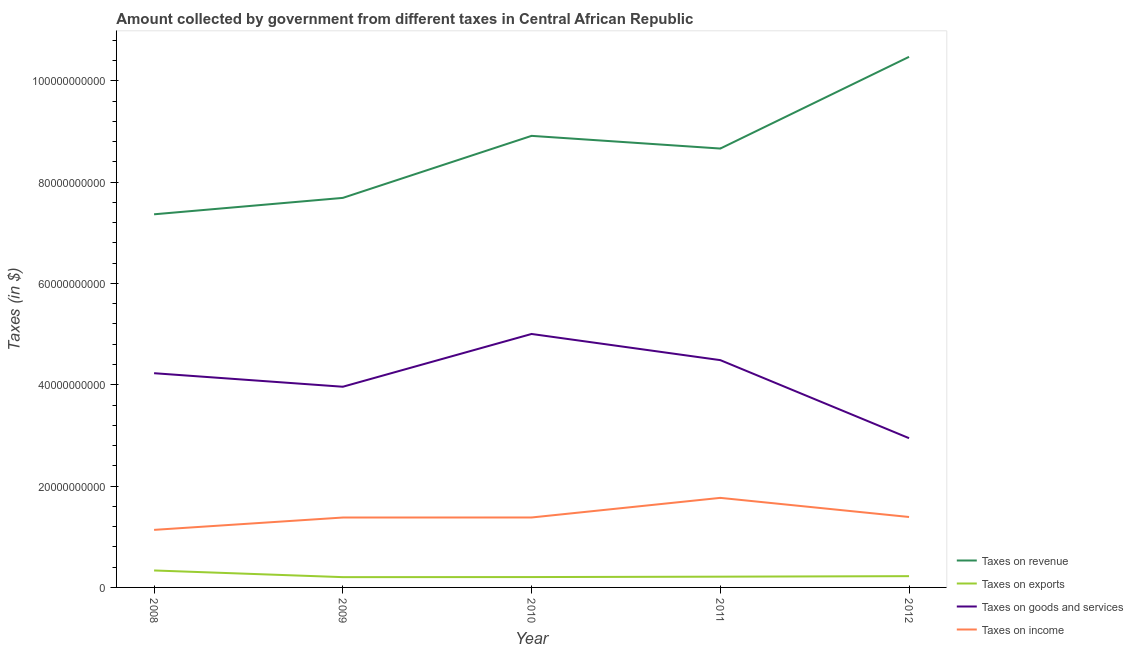What is the amount collected as tax on goods in 2008?
Ensure brevity in your answer.  4.23e+1. Across all years, what is the maximum amount collected as tax on exports?
Offer a terse response. 3.35e+09. Across all years, what is the minimum amount collected as tax on goods?
Keep it short and to the point. 2.95e+1. In which year was the amount collected as tax on goods maximum?
Your response must be concise. 2010. In which year was the amount collected as tax on revenue minimum?
Your response must be concise. 2008. What is the total amount collected as tax on goods in the graph?
Offer a terse response. 2.06e+11. What is the difference between the amount collected as tax on revenue in 2011 and that in 2012?
Make the answer very short. -1.81e+1. What is the difference between the amount collected as tax on exports in 2012 and the amount collected as tax on goods in 2008?
Ensure brevity in your answer.  -4.01e+1. What is the average amount collected as tax on exports per year?
Provide a succinct answer. 2.35e+09. In the year 2009, what is the difference between the amount collected as tax on income and amount collected as tax on goods?
Ensure brevity in your answer.  -2.58e+1. What is the ratio of the amount collected as tax on exports in 2008 to that in 2011?
Your response must be concise. 1.58. Is the difference between the amount collected as tax on goods in 2009 and 2011 greater than the difference between the amount collected as tax on income in 2009 and 2011?
Provide a succinct answer. No. What is the difference between the highest and the second highest amount collected as tax on revenue?
Offer a very short reply. 1.56e+1. What is the difference between the highest and the lowest amount collected as tax on goods?
Make the answer very short. 2.06e+1. Is it the case that in every year, the sum of the amount collected as tax on exports and amount collected as tax on goods is greater than the sum of amount collected as tax on revenue and amount collected as tax on income?
Your answer should be very brief. Yes. Is it the case that in every year, the sum of the amount collected as tax on revenue and amount collected as tax on exports is greater than the amount collected as tax on goods?
Offer a very short reply. Yes. Does the amount collected as tax on goods monotonically increase over the years?
Your answer should be compact. No. Is the amount collected as tax on revenue strictly greater than the amount collected as tax on goods over the years?
Your answer should be very brief. Yes. Is the amount collected as tax on revenue strictly less than the amount collected as tax on goods over the years?
Your response must be concise. No. How many lines are there?
Provide a short and direct response. 4. How many years are there in the graph?
Give a very brief answer. 5. Does the graph contain grids?
Provide a succinct answer. No. How many legend labels are there?
Your answer should be compact. 4. How are the legend labels stacked?
Your answer should be compact. Vertical. What is the title of the graph?
Give a very brief answer. Amount collected by government from different taxes in Central African Republic. Does "Others" appear as one of the legend labels in the graph?
Make the answer very short. No. What is the label or title of the X-axis?
Ensure brevity in your answer.  Year. What is the label or title of the Y-axis?
Your answer should be compact. Taxes (in $). What is the Taxes (in $) of Taxes on revenue in 2008?
Keep it short and to the point. 7.37e+1. What is the Taxes (in $) in Taxes on exports in 2008?
Your answer should be very brief. 3.35e+09. What is the Taxes (in $) of Taxes on goods and services in 2008?
Your response must be concise. 4.23e+1. What is the Taxes (in $) in Taxes on income in 2008?
Give a very brief answer. 1.14e+1. What is the Taxes (in $) of Taxes on revenue in 2009?
Your response must be concise. 7.69e+1. What is the Taxes (in $) of Taxes on exports in 2009?
Provide a short and direct response. 2.03e+09. What is the Taxes (in $) in Taxes on goods and services in 2009?
Your answer should be very brief. 3.96e+1. What is the Taxes (in $) of Taxes on income in 2009?
Provide a short and direct response. 1.38e+1. What is the Taxes (in $) in Taxes on revenue in 2010?
Provide a short and direct response. 8.91e+1. What is the Taxes (in $) in Taxes on exports in 2010?
Your answer should be compact. 2.05e+09. What is the Taxes (in $) in Taxes on goods and services in 2010?
Your answer should be compact. 5.00e+1. What is the Taxes (in $) of Taxes on income in 2010?
Provide a succinct answer. 1.38e+1. What is the Taxes (in $) of Taxes on revenue in 2011?
Provide a short and direct response. 8.66e+1. What is the Taxes (in $) of Taxes on exports in 2011?
Ensure brevity in your answer.  2.12e+09. What is the Taxes (in $) in Taxes on goods and services in 2011?
Offer a very short reply. 4.49e+1. What is the Taxes (in $) of Taxes on income in 2011?
Your response must be concise. 1.77e+1. What is the Taxes (in $) in Taxes on revenue in 2012?
Make the answer very short. 1.05e+11. What is the Taxes (in $) in Taxes on exports in 2012?
Provide a succinct answer. 2.23e+09. What is the Taxes (in $) of Taxes on goods and services in 2012?
Your response must be concise. 2.95e+1. What is the Taxes (in $) of Taxes on income in 2012?
Your answer should be very brief. 1.39e+1. Across all years, what is the maximum Taxes (in $) of Taxes on revenue?
Your response must be concise. 1.05e+11. Across all years, what is the maximum Taxes (in $) in Taxes on exports?
Your response must be concise. 3.35e+09. Across all years, what is the maximum Taxes (in $) of Taxes on goods and services?
Make the answer very short. 5.00e+1. Across all years, what is the maximum Taxes (in $) of Taxes on income?
Ensure brevity in your answer.  1.77e+1. Across all years, what is the minimum Taxes (in $) of Taxes on revenue?
Your response must be concise. 7.37e+1. Across all years, what is the minimum Taxes (in $) of Taxes on exports?
Your answer should be very brief. 2.03e+09. Across all years, what is the minimum Taxes (in $) in Taxes on goods and services?
Provide a short and direct response. 2.95e+1. Across all years, what is the minimum Taxes (in $) in Taxes on income?
Provide a short and direct response. 1.14e+1. What is the total Taxes (in $) of Taxes on revenue in the graph?
Your answer should be compact. 4.31e+11. What is the total Taxes (in $) of Taxes on exports in the graph?
Provide a short and direct response. 1.18e+1. What is the total Taxes (in $) in Taxes on goods and services in the graph?
Ensure brevity in your answer.  2.06e+11. What is the total Taxes (in $) in Taxes on income in the graph?
Provide a short and direct response. 7.05e+1. What is the difference between the Taxes (in $) of Taxes on revenue in 2008 and that in 2009?
Ensure brevity in your answer.  -3.24e+09. What is the difference between the Taxes (in $) of Taxes on exports in 2008 and that in 2009?
Your response must be concise. 1.32e+09. What is the difference between the Taxes (in $) of Taxes on goods and services in 2008 and that in 2009?
Keep it short and to the point. 2.67e+09. What is the difference between the Taxes (in $) of Taxes on income in 2008 and that in 2009?
Your response must be concise. -2.44e+09. What is the difference between the Taxes (in $) of Taxes on revenue in 2008 and that in 2010?
Make the answer very short. -1.55e+1. What is the difference between the Taxes (in $) in Taxes on exports in 2008 and that in 2010?
Provide a succinct answer. 1.30e+09. What is the difference between the Taxes (in $) in Taxes on goods and services in 2008 and that in 2010?
Give a very brief answer. -7.75e+09. What is the difference between the Taxes (in $) of Taxes on income in 2008 and that in 2010?
Provide a short and direct response. -2.44e+09. What is the difference between the Taxes (in $) of Taxes on revenue in 2008 and that in 2011?
Give a very brief answer. -1.30e+1. What is the difference between the Taxes (in $) in Taxes on exports in 2008 and that in 2011?
Keep it short and to the point. 1.22e+09. What is the difference between the Taxes (in $) of Taxes on goods and services in 2008 and that in 2011?
Keep it short and to the point. -2.58e+09. What is the difference between the Taxes (in $) of Taxes on income in 2008 and that in 2011?
Provide a succinct answer. -6.32e+09. What is the difference between the Taxes (in $) in Taxes on revenue in 2008 and that in 2012?
Provide a short and direct response. -3.11e+1. What is the difference between the Taxes (in $) in Taxes on exports in 2008 and that in 2012?
Give a very brief answer. 1.12e+09. What is the difference between the Taxes (in $) in Taxes on goods and services in 2008 and that in 2012?
Your answer should be very brief. 1.28e+1. What is the difference between the Taxes (in $) in Taxes on income in 2008 and that in 2012?
Make the answer very short. -2.54e+09. What is the difference between the Taxes (in $) in Taxes on revenue in 2009 and that in 2010?
Offer a terse response. -1.22e+1. What is the difference between the Taxes (in $) in Taxes on exports in 2009 and that in 2010?
Keep it short and to the point. -1.71e+07. What is the difference between the Taxes (in $) in Taxes on goods and services in 2009 and that in 2010?
Provide a short and direct response. -1.04e+1. What is the difference between the Taxes (in $) in Taxes on income in 2009 and that in 2010?
Provide a short and direct response. -7.21e+06. What is the difference between the Taxes (in $) of Taxes on revenue in 2009 and that in 2011?
Your answer should be very brief. -9.74e+09. What is the difference between the Taxes (in $) in Taxes on exports in 2009 and that in 2011?
Provide a short and direct response. -9.30e+07. What is the difference between the Taxes (in $) in Taxes on goods and services in 2009 and that in 2011?
Provide a short and direct response. -5.25e+09. What is the difference between the Taxes (in $) in Taxes on income in 2009 and that in 2011?
Keep it short and to the point. -3.88e+09. What is the difference between the Taxes (in $) of Taxes on revenue in 2009 and that in 2012?
Keep it short and to the point. -2.78e+1. What is the difference between the Taxes (in $) of Taxes on exports in 2009 and that in 2012?
Provide a short and direct response. -1.96e+08. What is the difference between the Taxes (in $) in Taxes on goods and services in 2009 and that in 2012?
Ensure brevity in your answer.  1.02e+1. What is the difference between the Taxes (in $) of Taxes on income in 2009 and that in 2012?
Provide a succinct answer. -1.05e+08. What is the difference between the Taxes (in $) in Taxes on revenue in 2010 and that in 2011?
Your response must be concise. 2.50e+09. What is the difference between the Taxes (in $) of Taxes on exports in 2010 and that in 2011?
Make the answer very short. -7.59e+07. What is the difference between the Taxes (in $) in Taxes on goods and services in 2010 and that in 2011?
Give a very brief answer. 5.16e+09. What is the difference between the Taxes (in $) of Taxes on income in 2010 and that in 2011?
Offer a very short reply. -3.87e+09. What is the difference between the Taxes (in $) of Taxes on revenue in 2010 and that in 2012?
Ensure brevity in your answer.  -1.56e+1. What is the difference between the Taxes (in $) of Taxes on exports in 2010 and that in 2012?
Make the answer very short. -1.79e+08. What is the difference between the Taxes (in $) of Taxes on goods and services in 2010 and that in 2012?
Provide a short and direct response. 2.06e+1. What is the difference between the Taxes (in $) of Taxes on income in 2010 and that in 2012?
Your answer should be very brief. -9.73e+07. What is the difference between the Taxes (in $) in Taxes on revenue in 2011 and that in 2012?
Provide a short and direct response. -1.81e+1. What is the difference between the Taxes (in $) in Taxes on exports in 2011 and that in 2012?
Ensure brevity in your answer.  -1.03e+08. What is the difference between the Taxes (in $) in Taxes on goods and services in 2011 and that in 2012?
Make the answer very short. 1.54e+1. What is the difference between the Taxes (in $) in Taxes on income in 2011 and that in 2012?
Your answer should be very brief. 3.78e+09. What is the difference between the Taxes (in $) in Taxes on revenue in 2008 and the Taxes (in $) in Taxes on exports in 2009?
Your answer should be very brief. 7.16e+1. What is the difference between the Taxes (in $) in Taxes on revenue in 2008 and the Taxes (in $) in Taxes on goods and services in 2009?
Offer a very short reply. 3.40e+1. What is the difference between the Taxes (in $) of Taxes on revenue in 2008 and the Taxes (in $) of Taxes on income in 2009?
Offer a terse response. 5.99e+1. What is the difference between the Taxes (in $) of Taxes on exports in 2008 and the Taxes (in $) of Taxes on goods and services in 2009?
Provide a succinct answer. -3.63e+1. What is the difference between the Taxes (in $) in Taxes on exports in 2008 and the Taxes (in $) in Taxes on income in 2009?
Offer a terse response. -1.05e+1. What is the difference between the Taxes (in $) of Taxes on goods and services in 2008 and the Taxes (in $) of Taxes on income in 2009?
Offer a terse response. 2.85e+1. What is the difference between the Taxes (in $) of Taxes on revenue in 2008 and the Taxes (in $) of Taxes on exports in 2010?
Give a very brief answer. 7.16e+1. What is the difference between the Taxes (in $) in Taxes on revenue in 2008 and the Taxes (in $) in Taxes on goods and services in 2010?
Provide a short and direct response. 2.36e+1. What is the difference between the Taxes (in $) of Taxes on revenue in 2008 and the Taxes (in $) of Taxes on income in 2010?
Make the answer very short. 5.98e+1. What is the difference between the Taxes (in $) of Taxes on exports in 2008 and the Taxes (in $) of Taxes on goods and services in 2010?
Offer a terse response. -4.67e+1. What is the difference between the Taxes (in $) in Taxes on exports in 2008 and the Taxes (in $) in Taxes on income in 2010?
Provide a succinct answer. -1.05e+1. What is the difference between the Taxes (in $) of Taxes on goods and services in 2008 and the Taxes (in $) of Taxes on income in 2010?
Keep it short and to the point. 2.85e+1. What is the difference between the Taxes (in $) of Taxes on revenue in 2008 and the Taxes (in $) of Taxes on exports in 2011?
Offer a very short reply. 7.15e+1. What is the difference between the Taxes (in $) in Taxes on revenue in 2008 and the Taxes (in $) in Taxes on goods and services in 2011?
Provide a succinct answer. 2.88e+1. What is the difference between the Taxes (in $) in Taxes on revenue in 2008 and the Taxes (in $) in Taxes on income in 2011?
Your answer should be very brief. 5.60e+1. What is the difference between the Taxes (in $) in Taxes on exports in 2008 and the Taxes (in $) in Taxes on goods and services in 2011?
Provide a short and direct response. -4.15e+1. What is the difference between the Taxes (in $) of Taxes on exports in 2008 and the Taxes (in $) of Taxes on income in 2011?
Offer a terse response. -1.43e+1. What is the difference between the Taxes (in $) of Taxes on goods and services in 2008 and the Taxes (in $) of Taxes on income in 2011?
Your answer should be very brief. 2.46e+1. What is the difference between the Taxes (in $) in Taxes on revenue in 2008 and the Taxes (in $) in Taxes on exports in 2012?
Keep it short and to the point. 7.14e+1. What is the difference between the Taxes (in $) of Taxes on revenue in 2008 and the Taxes (in $) of Taxes on goods and services in 2012?
Your response must be concise. 4.42e+1. What is the difference between the Taxes (in $) of Taxes on revenue in 2008 and the Taxes (in $) of Taxes on income in 2012?
Provide a short and direct response. 5.97e+1. What is the difference between the Taxes (in $) of Taxes on exports in 2008 and the Taxes (in $) of Taxes on goods and services in 2012?
Keep it short and to the point. -2.61e+1. What is the difference between the Taxes (in $) in Taxes on exports in 2008 and the Taxes (in $) in Taxes on income in 2012?
Make the answer very short. -1.06e+1. What is the difference between the Taxes (in $) in Taxes on goods and services in 2008 and the Taxes (in $) in Taxes on income in 2012?
Keep it short and to the point. 2.84e+1. What is the difference between the Taxes (in $) of Taxes on revenue in 2009 and the Taxes (in $) of Taxes on exports in 2010?
Keep it short and to the point. 7.48e+1. What is the difference between the Taxes (in $) of Taxes on revenue in 2009 and the Taxes (in $) of Taxes on goods and services in 2010?
Keep it short and to the point. 2.69e+1. What is the difference between the Taxes (in $) in Taxes on revenue in 2009 and the Taxes (in $) in Taxes on income in 2010?
Ensure brevity in your answer.  6.31e+1. What is the difference between the Taxes (in $) in Taxes on exports in 2009 and the Taxes (in $) in Taxes on goods and services in 2010?
Give a very brief answer. -4.80e+1. What is the difference between the Taxes (in $) of Taxes on exports in 2009 and the Taxes (in $) of Taxes on income in 2010?
Your response must be concise. -1.18e+1. What is the difference between the Taxes (in $) in Taxes on goods and services in 2009 and the Taxes (in $) in Taxes on income in 2010?
Offer a very short reply. 2.58e+1. What is the difference between the Taxes (in $) in Taxes on revenue in 2009 and the Taxes (in $) in Taxes on exports in 2011?
Give a very brief answer. 7.48e+1. What is the difference between the Taxes (in $) in Taxes on revenue in 2009 and the Taxes (in $) in Taxes on goods and services in 2011?
Your answer should be very brief. 3.20e+1. What is the difference between the Taxes (in $) in Taxes on revenue in 2009 and the Taxes (in $) in Taxes on income in 2011?
Give a very brief answer. 5.92e+1. What is the difference between the Taxes (in $) in Taxes on exports in 2009 and the Taxes (in $) in Taxes on goods and services in 2011?
Offer a terse response. -4.28e+1. What is the difference between the Taxes (in $) in Taxes on exports in 2009 and the Taxes (in $) in Taxes on income in 2011?
Give a very brief answer. -1.56e+1. What is the difference between the Taxes (in $) in Taxes on goods and services in 2009 and the Taxes (in $) in Taxes on income in 2011?
Ensure brevity in your answer.  2.19e+1. What is the difference between the Taxes (in $) in Taxes on revenue in 2009 and the Taxes (in $) in Taxes on exports in 2012?
Make the answer very short. 7.47e+1. What is the difference between the Taxes (in $) of Taxes on revenue in 2009 and the Taxes (in $) of Taxes on goods and services in 2012?
Give a very brief answer. 4.74e+1. What is the difference between the Taxes (in $) in Taxes on revenue in 2009 and the Taxes (in $) in Taxes on income in 2012?
Keep it short and to the point. 6.30e+1. What is the difference between the Taxes (in $) of Taxes on exports in 2009 and the Taxes (in $) of Taxes on goods and services in 2012?
Give a very brief answer. -2.74e+1. What is the difference between the Taxes (in $) in Taxes on exports in 2009 and the Taxes (in $) in Taxes on income in 2012?
Ensure brevity in your answer.  -1.19e+1. What is the difference between the Taxes (in $) in Taxes on goods and services in 2009 and the Taxes (in $) in Taxes on income in 2012?
Ensure brevity in your answer.  2.57e+1. What is the difference between the Taxes (in $) in Taxes on revenue in 2010 and the Taxes (in $) in Taxes on exports in 2011?
Offer a terse response. 8.70e+1. What is the difference between the Taxes (in $) in Taxes on revenue in 2010 and the Taxes (in $) in Taxes on goods and services in 2011?
Make the answer very short. 4.43e+1. What is the difference between the Taxes (in $) in Taxes on revenue in 2010 and the Taxes (in $) in Taxes on income in 2011?
Provide a short and direct response. 7.15e+1. What is the difference between the Taxes (in $) of Taxes on exports in 2010 and the Taxes (in $) of Taxes on goods and services in 2011?
Ensure brevity in your answer.  -4.28e+1. What is the difference between the Taxes (in $) of Taxes on exports in 2010 and the Taxes (in $) of Taxes on income in 2011?
Make the answer very short. -1.56e+1. What is the difference between the Taxes (in $) of Taxes on goods and services in 2010 and the Taxes (in $) of Taxes on income in 2011?
Make the answer very short. 3.24e+1. What is the difference between the Taxes (in $) of Taxes on revenue in 2010 and the Taxes (in $) of Taxes on exports in 2012?
Offer a very short reply. 8.69e+1. What is the difference between the Taxes (in $) of Taxes on revenue in 2010 and the Taxes (in $) of Taxes on goods and services in 2012?
Provide a succinct answer. 5.97e+1. What is the difference between the Taxes (in $) in Taxes on revenue in 2010 and the Taxes (in $) in Taxes on income in 2012?
Provide a succinct answer. 7.52e+1. What is the difference between the Taxes (in $) of Taxes on exports in 2010 and the Taxes (in $) of Taxes on goods and services in 2012?
Keep it short and to the point. -2.74e+1. What is the difference between the Taxes (in $) in Taxes on exports in 2010 and the Taxes (in $) in Taxes on income in 2012?
Provide a succinct answer. -1.19e+1. What is the difference between the Taxes (in $) of Taxes on goods and services in 2010 and the Taxes (in $) of Taxes on income in 2012?
Offer a very short reply. 3.61e+1. What is the difference between the Taxes (in $) of Taxes on revenue in 2011 and the Taxes (in $) of Taxes on exports in 2012?
Ensure brevity in your answer.  8.44e+1. What is the difference between the Taxes (in $) in Taxes on revenue in 2011 and the Taxes (in $) in Taxes on goods and services in 2012?
Keep it short and to the point. 5.72e+1. What is the difference between the Taxes (in $) in Taxes on revenue in 2011 and the Taxes (in $) in Taxes on income in 2012?
Provide a short and direct response. 7.27e+1. What is the difference between the Taxes (in $) of Taxes on exports in 2011 and the Taxes (in $) of Taxes on goods and services in 2012?
Offer a very short reply. -2.73e+1. What is the difference between the Taxes (in $) of Taxes on exports in 2011 and the Taxes (in $) of Taxes on income in 2012?
Provide a succinct answer. -1.18e+1. What is the difference between the Taxes (in $) in Taxes on goods and services in 2011 and the Taxes (in $) in Taxes on income in 2012?
Provide a succinct answer. 3.10e+1. What is the average Taxes (in $) in Taxes on revenue per year?
Offer a very short reply. 8.62e+1. What is the average Taxes (in $) of Taxes on exports per year?
Ensure brevity in your answer.  2.35e+09. What is the average Taxes (in $) of Taxes on goods and services per year?
Your response must be concise. 4.13e+1. What is the average Taxes (in $) of Taxes on income per year?
Offer a very short reply. 1.41e+1. In the year 2008, what is the difference between the Taxes (in $) of Taxes on revenue and Taxes (in $) of Taxes on exports?
Provide a succinct answer. 7.03e+1. In the year 2008, what is the difference between the Taxes (in $) of Taxes on revenue and Taxes (in $) of Taxes on goods and services?
Your answer should be very brief. 3.14e+1. In the year 2008, what is the difference between the Taxes (in $) of Taxes on revenue and Taxes (in $) of Taxes on income?
Keep it short and to the point. 6.23e+1. In the year 2008, what is the difference between the Taxes (in $) in Taxes on exports and Taxes (in $) in Taxes on goods and services?
Provide a succinct answer. -3.89e+1. In the year 2008, what is the difference between the Taxes (in $) of Taxes on exports and Taxes (in $) of Taxes on income?
Your answer should be compact. -8.02e+09. In the year 2008, what is the difference between the Taxes (in $) of Taxes on goods and services and Taxes (in $) of Taxes on income?
Offer a very short reply. 3.09e+1. In the year 2009, what is the difference between the Taxes (in $) of Taxes on revenue and Taxes (in $) of Taxes on exports?
Your answer should be very brief. 7.49e+1. In the year 2009, what is the difference between the Taxes (in $) in Taxes on revenue and Taxes (in $) in Taxes on goods and services?
Ensure brevity in your answer.  3.73e+1. In the year 2009, what is the difference between the Taxes (in $) in Taxes on revenue and Taxes (in $) in Taxes on income?
Keep it short and to the point. 6.31e+1. In the year 2009, what is the difference between the Taxes (in $) in Taxes on exports and Taxes (in $) in Taxes on goods and services?
Make the answer very short. -3.76e+1. In the year 2009, what is the difference between the Taxes (in $) of Taxes on exports and Taxes (in $) of Taxes on income?
Your response must be concise. -1.18e+1. In the year 2009, what is the difference between the Taxes (in $) of Taxes on goods and services and Taxes (in $) of Taxes on income?
Keep it short and to the point. 2.58e+1. In the year 2010, what is the difference between the Taxes (in $) in Taxes on revenue and Taxes (in $) in Taxes on exports?
Ensure brevity in your answer.  8.71e+1. In the year 2010, what is the difference between the Taxes (in $) in Taxes on revenue and Taxes (in $) in Taxes on goods and services?
Your response must be concise. 3.91e+1. In the year 2010, what is the difference between the Taxes (in $) of Taxes on revenue and Taxes (in $) of Taxes on income?
Keep it short and to the point. 7.53e+1. In the year 2010, what is the difference between the Taxes (in $) in Taxes on exports and Taxes (in $) in Taxes on goods and services?
Give a very brief answer. -4.80e+1. In the year 2010, what is the difference between the Taxes (in $) in Taxes on exports and Taxes (in $) in Taxes on income?
Your response must be concise. -1.18e+1. In the year 2010, what is the difference between the Taxes (in $) in Taxes on goods and services and Taxes (in $) in Taxes on income?
Keep it short and to the point. 3.62e+1. In the year 2011, what is the difference between the Taxes (in $) in Taxes on revenue and Taxes (in $) in Taxes on exports?
Offer a terse response. 8.45e+1. In the year 2011, what is the difference between the Taxes (in $) of Taxes on revenue and Taxes (in $) of Taxes on goods and services?
Keep it short and to the point. 4.18e+1. In the year 2011, what is the difference between the Taxes (in $) of Taxes on revenue and Taxes (in $) of Taxes on income?
Ensure brevity in your answer.  6.90e+1. In the year 2011, what is the difference between the Taxes (in $) of Taxes on exports and Taxes (in $) of Taxes on goods and services?
Offer a terse response. -4.27e+1. In the year 2011, what is the difference between the Taxes (in $) in Taxes on exports and Taxes (in $) in Taxes on income?
Your answer should be very brief. -1.56e+1. In the year 2011, what is the difference between the Taxes (in $) in Taxes on goods and services and Taxes (in $) in Taxes on income?
Give a very brief answer. 2.72e+1. In the year 2012, what is the difference between the Taxes (in $) in Taxes on revenue and Taxes (in $) in Taxes on exports?
Your answer should be compact. 1.03e+11. In the year 2012, what is the difference between the Taxes (in $) of Taxes on revenue and Taxes (in $) of Taxes on goods and services?
Your answer should be compact. 7.53e+1. In the year 2012, what is the difference between the Taxes (in $) in Taxes on revenue and Taxes (in $) in Taxes on income?
Make the answer very short. 9.08e+1. In the year 2012, what is the difference between the Taxes (in $) of Taxes on exports and Taxes (in $) of Taxes on goods and services?
Your response must be concise. -2.72e+1. In the year 2012, what is the difference between the Taxes (in $) of Taxes on exports and Taxes (in $) of Taxes on income?
Give a very brief answer. -1.17e+1. In the year 2012, what is the difference between the Taxes (in $) of Taxes on goods and services and Taxes (in $) of Taxes on income?
Keep it short and to the point. 1.56e+1. What is the ratio of the Taxes (in $) in Taxes on revenue in 2008 to that in 2009?
Your answer should be compact. 0.96. What is the ratio of the Taxes (in $) in Taxes on exports in 2008 to that in 2009?
Your response must be concise. 1.65. What is the ratio of the Taxes (in $) in Taxes on goods and services in 2008 to that in 2009?
Provide a succinct answer. 1.07. What is the ratio of the Taxes (in $) in Taxes on income in 2008 to that in 2009?
Offer a very short reply. 0.82. What is the ratio of the Taxes (in $) in Taxes on revenue in 2008 to that in 2010?
Your answer should be compact. 0.83. What is the ratio of the Taxes (in $) in Taxes on exports in 2008 to that in 2010?
Provide a short and direct response. 1.63. What is the ratio of the Taxes (in $) in Taxes on goods and services in 2008 to that in 2010?
Give a very brief answer. 0.85. What is the ratio of the Taxes (in $) in Taxes on income in 2008 to that in 2010?
Make the answer very short. 0.82. What is the ratio of the Taxes (in $) of Taxes on revenue in 2008 to that in 2011?
Offer a very short reply. 0.85. What is the ratio of the Taxes (in $) of Taxes on exports in 2008 to that in 2011?
Provide a succinct answer. 1.58. What is the ratio of the Taxes (in $) of Taxes on goods and services in 2008 to that in 2011?
Provide a short and direct response. 0.94. What is the ratio of the Taxes (in $) of Taxes on income in 2008 to that in 2011?
Your answer should be compact. 0.64. What is the ratio of the Taxes (in $) of Taxes on revenue in 2008 to that in 2012?
Offer a terse response. 0.7. What is the ratio of the Taxes (in $) of Taxes on exports in 2008 to that in 2012?
Offer a terse response. 1.5. What is the ratio of the Taxes (in $) in Taxes on goods and services in 2008 to that in 2012?
Offer a terse response. 1.44. What is the ratio of the Taxes (in $) of Taxes on income in 2008 to that in 2012?
Ensure brevity in your answer.  0.82. What is the ratio of the Taxes (in $) of Taxes on revenue in 2009 to that in 2010?
Your answer should be compact. 0.86. What is the ratio of the Taxes (in $) of Taxes on goods and services in 2009 to that in 2010?
Offer a very short reply. 0.79. What is the ratio of the Taxes (in $) of Taxes on revenue in 2009 to that in 2011?
Offer a very short reply. 0.89. What is the ratio of the Taxes (in $) of Taxes on exports in 2009 to that in 2011?
Make the answer very short. 0.96. What is the ratio of the Taxes (in $) of Taxes on goods and services in 2009 to that in 2011?
Ensure brevity in your answer.  0.88. What is the ratio of the Taxes (in $) in Taxes on income in 2009 to that in 2011?
Offer a terse response. 0.78. What is the ratio of the Taxes (in $) of Taxes on revenue in 2009 to that in 2012?
Make the answer very short. 0.73. What is the ratio of the Taxes (in $) of Taxes on exports in 2009 to that in 2012?
Ensure brevity in your answer.  0.91. What is the ratio of the Taxes (in $) in Taxes on goods and services in 2009 to that in 2012?
Provide a short and direct response. 1.34. What is the ratio of the Taxes (in $) in Taxes on income in 2009 to that in 2012?
Offer a very short reply. 0.99. What is the ratio of the Taxes (in $) of Taxes on revenue in 2010 to that in 2011?
Keep it short and to the point. 1.03. What is the ratio of the Taxes (in $) in Taxes on exports in 2010 to that in 2011?
Offer a terse response. 0.96. What is the ratio of the Taxes (in $) of Taxes on goods and services in 2010 to that in 2011?
Provide a succinct answer. 1.12. What is the ratio of the Taxes (in $) of Taxes on income in 2010 to that in 2011?
Offer a very short reply. 0.78. What is the ratio of the Taxes (in $) in Taxes on revenue in 2010 to that in 2012?
Ensure brevity in your answer.  0.85. What is the ratio of the Taxes (in $) of Taxes on exports in 2010 to that in 2012?
Your response must be concise. 0.92. What is the ratio of the Taxes (in $) of Taxes on goods and services in 2010 to that in 2012?
Your answer should be compact. 1.7. What is the ratio of the Taxes (in $) in Taxes on income in 2010 to that in 2012?
Keep it short and to the point. 0.99. What is the ratio of the Taxes (in $) of Taxes on revenue in 2011 to that in 2012?
Keep it short and to the point. 0.83. What is the ratio of the Taxes (in $) in Taxes on exports in 2011 to that in 2012?
Your response must be concise. 0.95. What is the ratio of the Taxes (in $) of Taxes on goods and services in 2011 to that in 2012?
Provide a succinct answer. 1.52. What is the ratio of the Taxes (in $) of Taxes on income in 2011 to that in 2012?
Make the answer very short. 1.27. What is the difference between the highest and the second highest Taxes (in $) in Taxes on revenue?
Ensure brevity in your answer.  1.56e+1. What is the difference between the highest and the second highest Taxes (in $) of Taxes on exports?
Give a very brief answer. 1.12e+09. What is the difference between the highest and the second highest Taxes (in $) in Taxes on goods and services?
Ensure brevity in your answer.  5.16e+09. What is the difference between the highest and the second highest Taxes (in $) in Taxes on income?
Your answer should be compact. 3.78e+09. What is the difference between the highest and the lowest Taxes (in $) in Taxes on revenue?
Provide a succinct answer. 3.11e+1. What is the difference between the highest and the lowest Taxes (in $) in Taxes on exports?
Your answer should be very brief. 1.32e+09. What is the difference between the highest and the lowest Taxes (in $) in Taxes on goods and services?
Keep it short and to the point. 2.06e+1. What is the difference between the highest and the lowest Taxes (in $) in Taxes on income?
Offer a terse response. 6.32e+09. 